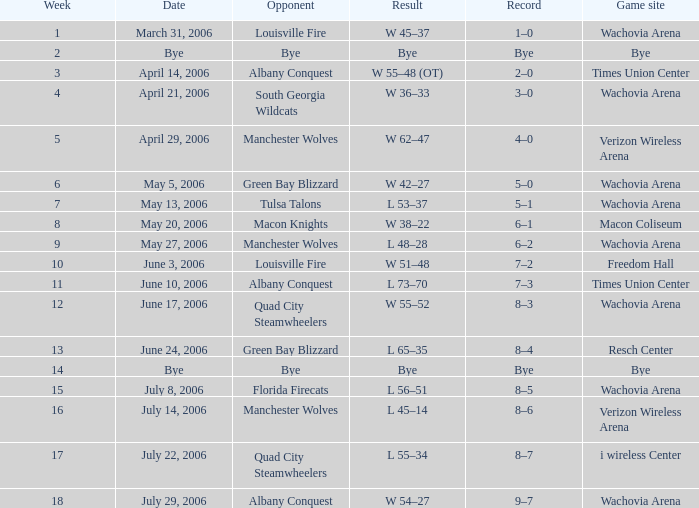What team was the opponent in a week earlier than 17 on June 17, 2006? Quad City Steamwheelers. Would you mind parsing the complete table? {'header': ['Week', 'Date', 'Opponent', 'Result', 'Record', 'Game site'], 'rows': [['1', 'March 31, 2006', 'Louisville Fire', 'W 45–37', '1–0', 'Wachovia Arena'], ['2', 'Bye', 'Bye', 'Bye', 'Bye', 'Bye'], ['3', 'April 14, 2006', 'Albany Conquest', 'W 55–48 (OT)', '2–0', 'Times Union Center'], ['4', 'April 21, 2006', 'South Georgia Wildcats', 'W 36–33', '3–0', 'Wachovia Arena'], ['5', 'April 29, 2006', 'Manchester Wolves', 'W 62–47', '4–0', 'Verizon Wireless Arena'], ['6', 'May 5, 2006', 'Green Bay Blizzard', 'W 42–27', '5–0', 'Wachovia Arena'], ['7', 'May 13, 2006', 'Tulsa Talons', 'L 53–37', '5–1', 'Wachovia Arena'], ['8', 'May 20, 2006', 'Macon Knights', 'W 38–22', '6–1', 'Macon Coliseum'], ['9', 'May 27, 2006', 'Manchester Wolves', 'L 48–28', '6–2', 'Wachovia Arena'], ['10', 'June 3, 2006', 'Louisville Fire', 'W 51–48', '7–2', 'Freedom Hall'], ['11', 'June 10, 2006', 'Albany Conquest', 'L 73–70', '7–3', 'Times Union Center'], ['12', 'June 17, 2006', 'Quad City Steamwheelers', 'W 55–52', '8–3', 'Wachovia Arena'], ['13', 'June 24, 2006', 'Green Bay Blizzard', 'L 65–35', '8–4', 'Resch Center'], ['14', 'Bye', 'Bye', 'Bye', 'Bye', 'Bye'], ['15', 'July 8, 2006', 'Florida Firecats', 'L 56–51', '8–5', 'Wachovia Arena'], ['16', 'July 14, 2006', 'Manchester Wolves', 'L 45–14', '8–6', 'Verizon Wireless Arena'], ['17', 'July 22, 2006', 'Quad City Steamwheelers', 'L 55–34', '8–7', 'i wireless Center'], ['18', 'July 29, 2006', 'Albany Conquest', 'W 54–27', '9–7', 'Wachovia Arena']]} 